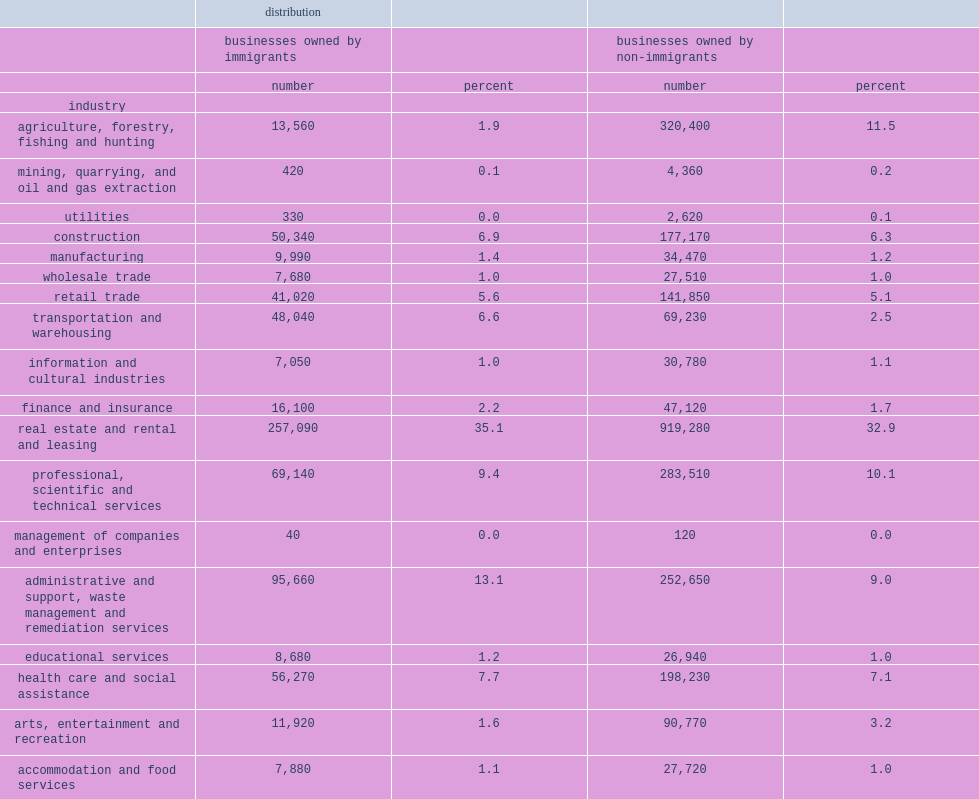Which industry is the largest single industry by far among the immigrant self-employed? Real estate and rental and leasing. What the percent of real estate and rental and leasing accounting for unincorporated self-employed immigrants among the immigrant self-employed? 35.1. 